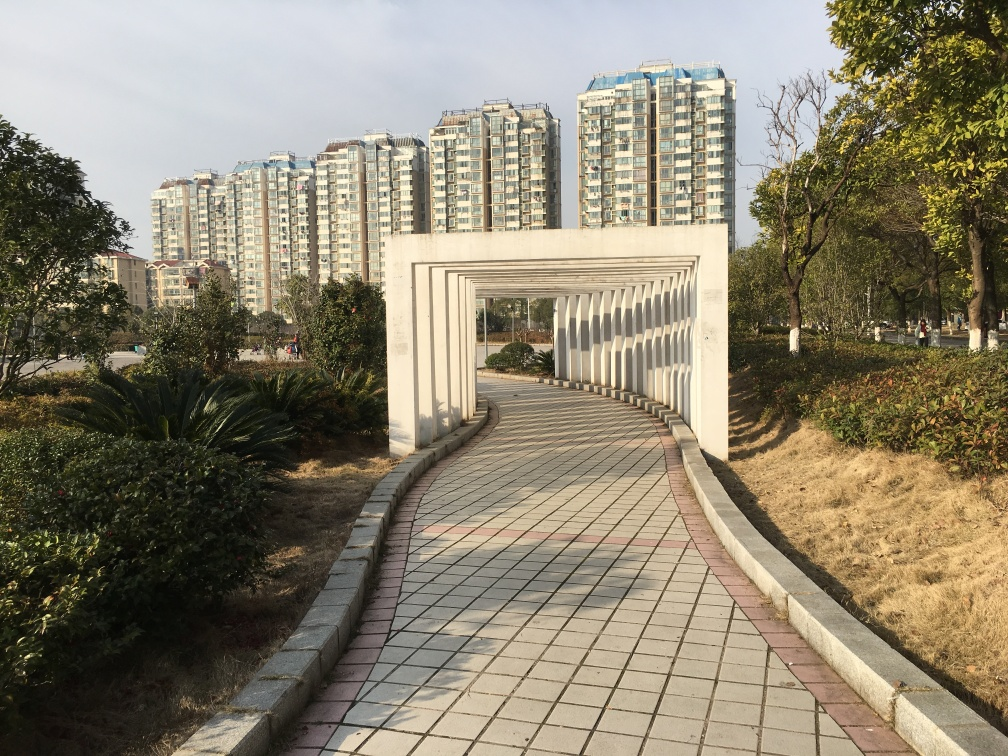What time of year does this photo seem to be taken in? Based on the foliage and the quality of light, it appears to be taken during late fall or early spring, when trees have not fully leaved out yet. 